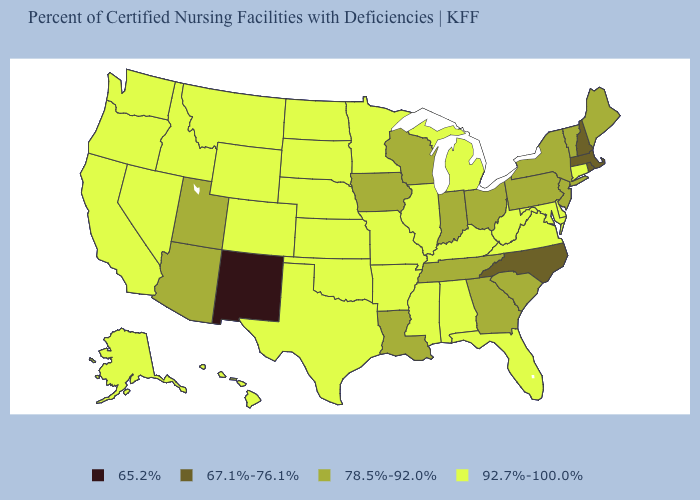What is the value of Kentucky?
Short answer required. 92.7%-100.0%. Which states hav the highest value in the West?
Short answer required. Alaska, California, Colorado, Hawaii, Idaho, Montana, Nevada, Oregon, Washington, Wyoming. What is the value of Maine?
Give a very brief answer. 78.5%-92.0%. What is the highest value in the USA?
Short answer required. 92.7%-100.0%. Name the states that have a value in the range 67.1%-76.1%?
Concise answer only. Massachusetts, New Hampshire, North Carolina, Rhode Island. What is the lowest value in states that border New Mexico?
Be succinct. 78.5%-92.0%. Does the map have missing data?
Concise answer only. No. Among the states that border Arkansas , which have the highest value?
Give a very brief answer. Mississippi, Missouri, Oklahoma, Texas. What is the value of Indiana?
Short answer required. 78.5%-92.0%. What is the lowest value in states that border Delaware?
Short answer required. 78.5%-92.0%. Name the states that have a value in the range 92.7%-100.0%?
Give a very brief answer. Alabama, Alaska, Arkansas, California, Colorado, Connecticut, Delaware, Florida, Hawaii, Idaho, Illinois, Kansas, Kentucky, Maryland, Michigan, Minnesota, Mississippi, Missouri, Montana, Nebraska, Nevada, North Dakota, Oklahoma, Oregon, South Dakota, Texas, Virginia, Washington, West Virginia, Wyoming. Does New Mexico have the lowest value in the USA?
Give a very brief answer. Yes. Does Vermont have the highest value in the USA?
Answer briefly. No. Which states have the highest value in the USA?
Keep it brief. Alabama, Alaska, Arkansas, California, Colorado, Connecticut, Delaware, Florida, Hawaii, Idaho, Illinois, Kansas, Kentucky, Maryland, Michigan, Minnesota, Mississippi, Missouri, Montana, Nebraska, Nevada, North Dakota, Oklahoma, Oregon, South Dakota, Texas, Virginia, Washington, West Virginia, Wyoming. What is the lowest value in states that border Maryland?
Write a very short answer. 78.5%-92.0%. 